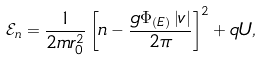Convert formula to latex. <formula><loc_0><loc_0><loc_500><loc_500>\mathcal { E } _ { n } = \frac { 1 } { 2 m r _ { 0 } ^ { 2 } } \left [ n - \frac { g \Phi _ { \left ( E \right ) } \left | v \right | } { 2 \pi } \right ] ^ { 2 } + q U ,</formula> 